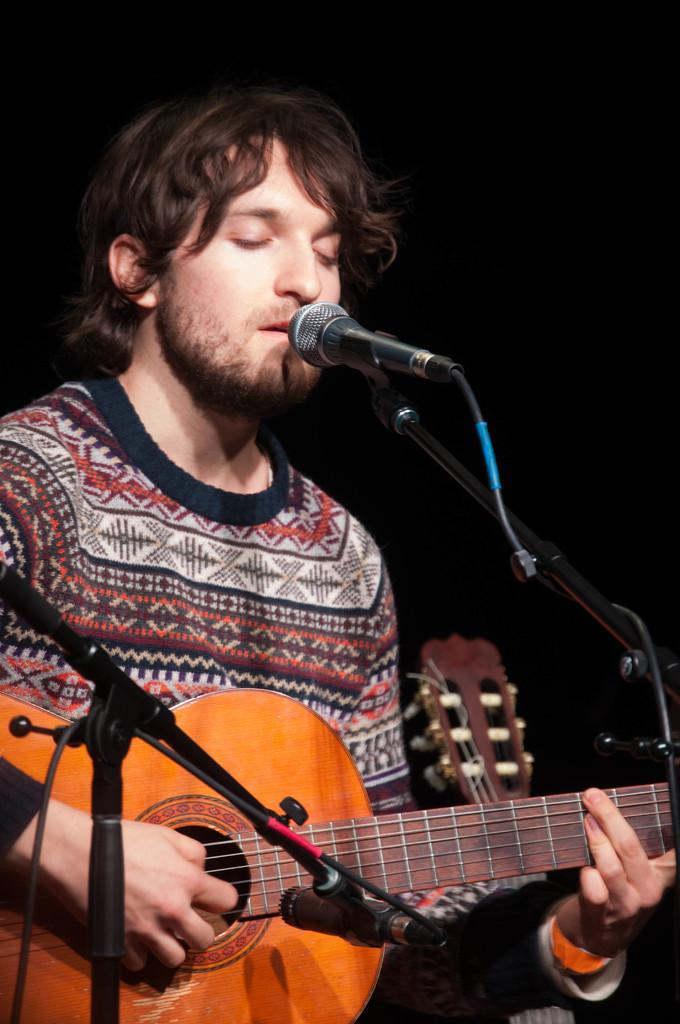What is the man in the image doing? The man is playing the guitar and singing into a microphone. How is the man interacting with the guitar? The man is using his hands while playing the guitar. What type of dolls can be seen on the table during the man's performance? There are no dolls present in the image; it features a man playing the guitar and singing into a microphone. 